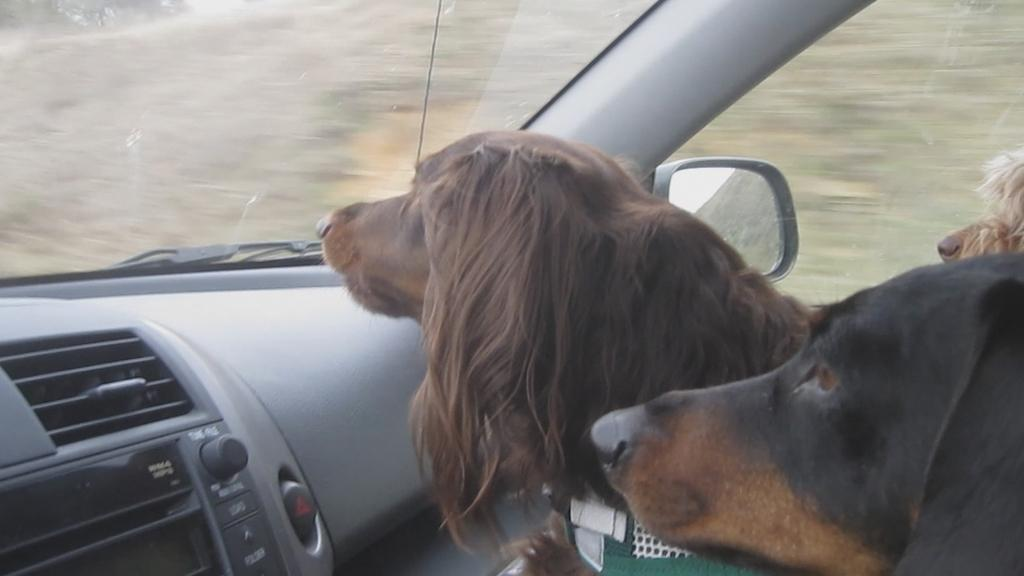How many dogs are present in the image? There are three dogs in the image. Where are the dogs located? The dogs are inside a car. What part of the car can be seen in the image? The dashboard is visible in the car. What type of property can be seen in the background of the image? There is no property visible in the background of the image; it only shows the interior of a car with the dogs and the dashboard. 